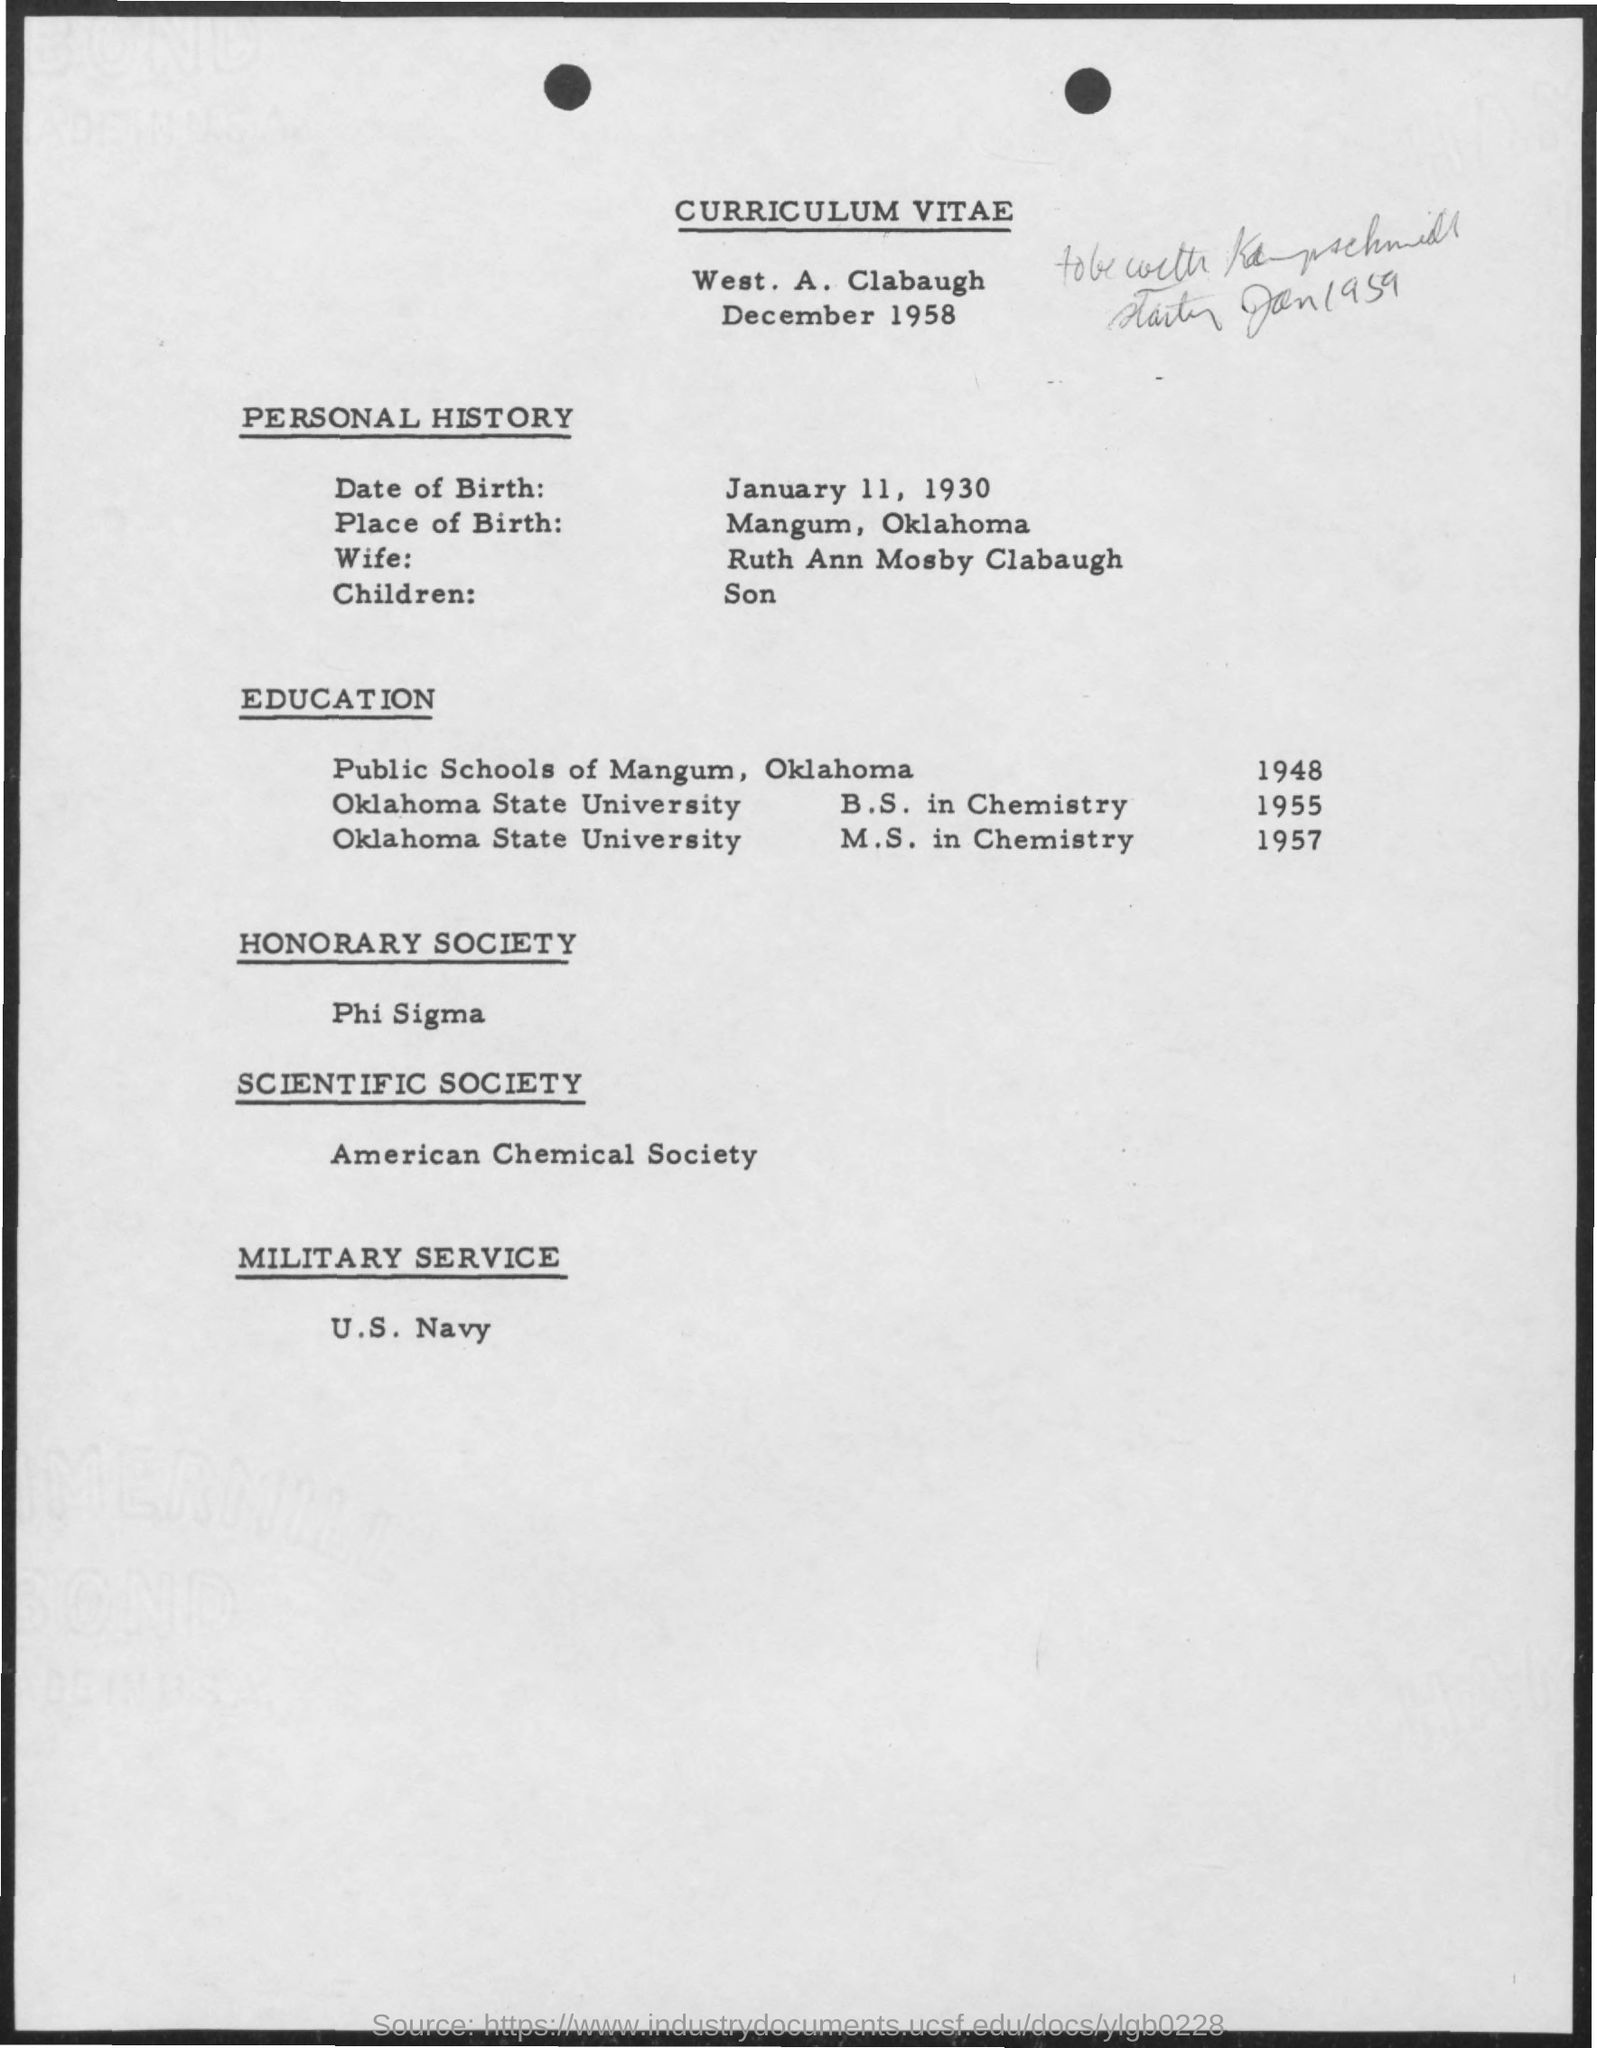What is the date of birth mentioned in the given page ?
Make the answer very short. January 11, 1930. What is the place of birth mentioned in the given page ?
Offer a terse response. Mangum, oklahoma. What is the name of the wife mentioned ?
Ensure brevity in your answer.  Ruth ann mosby clabaugh. What is the children mentioned ?
Make the answer very short. Son. What is the name of scientific society mentioned ?
Offer a terse response. American chemical society. What is the name of honorary society mentioned ?
Your answer should be compact. Phi sigma. 